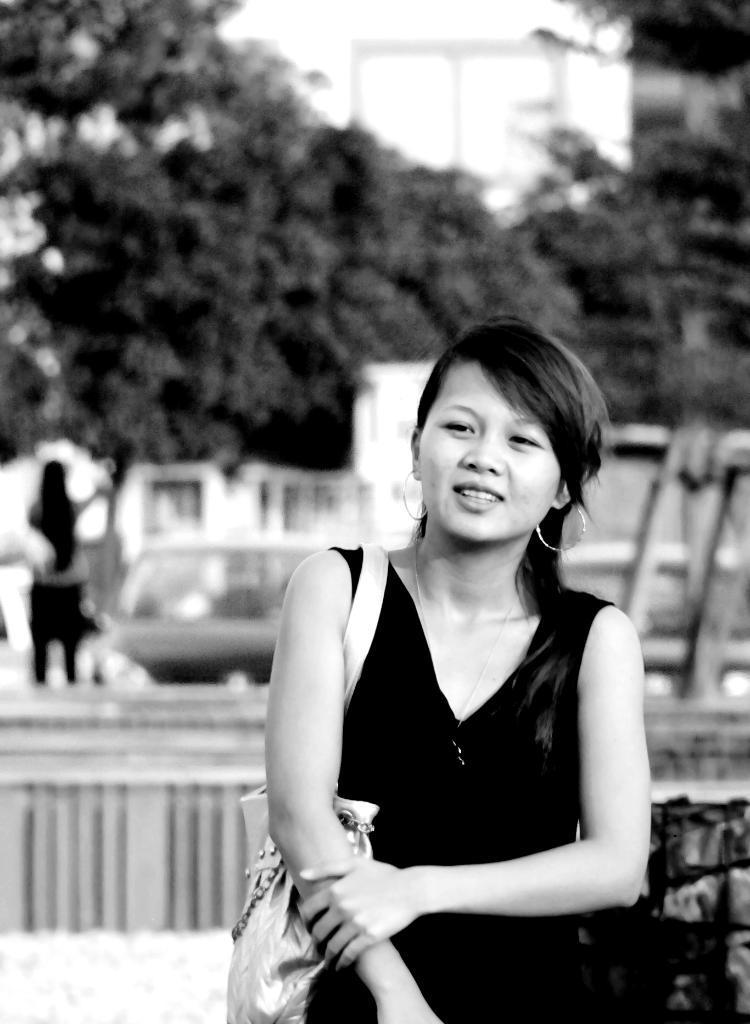Could you give a brief overview of what you see in this image? This is a black and white image. In this image, in the middle, we can see a woman wearing a handbag. On the left side, we can also see another woman is standing. In the background, we can see some vehicles, trees, building. At the top, we can see a sky. 